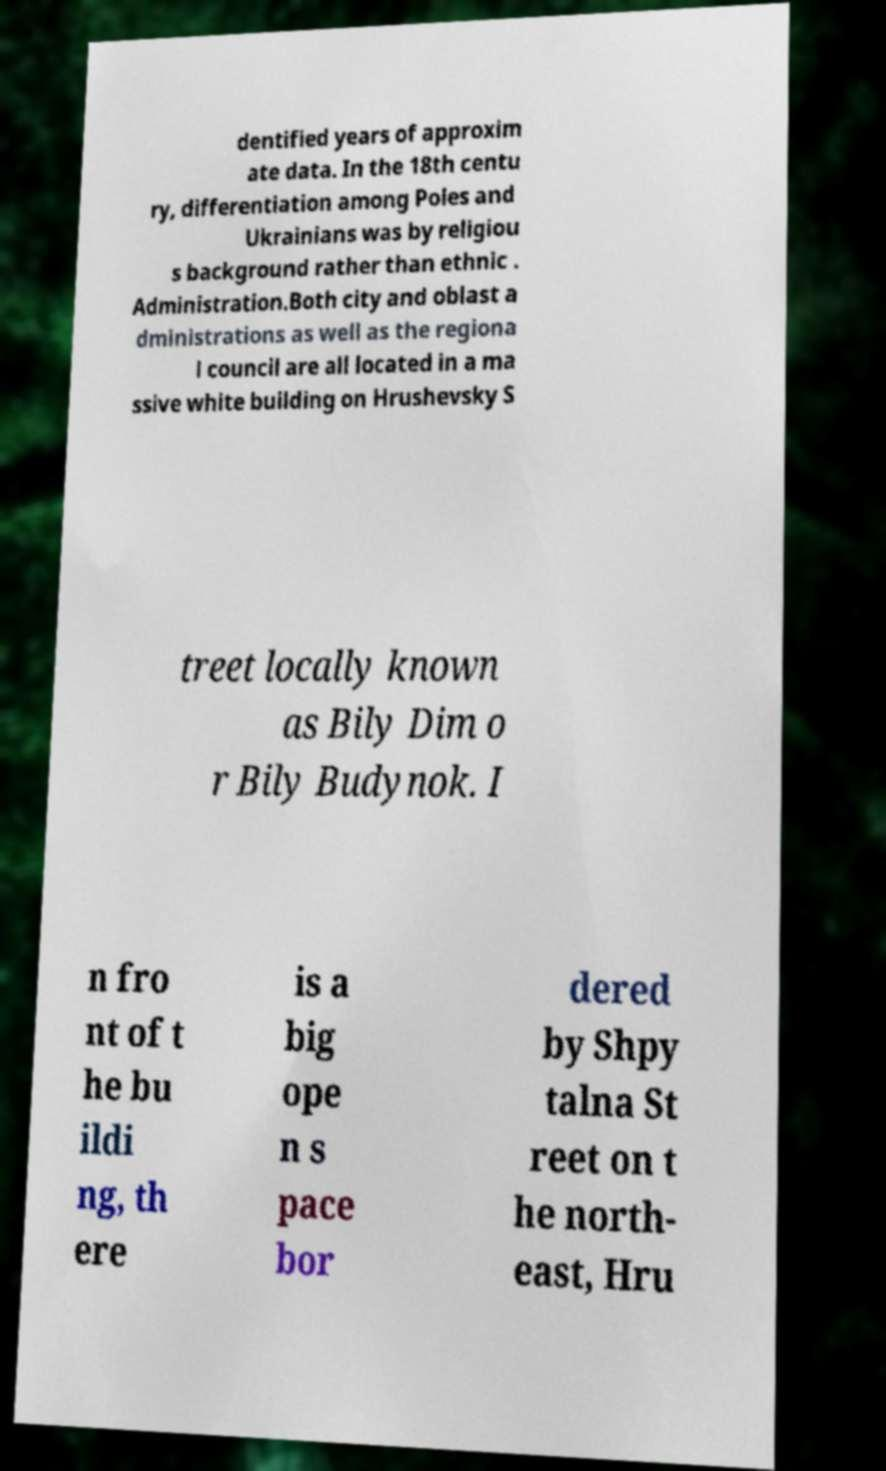Please identify and transcribe the text found in this image. dentified years of approxim ate data. In the 18th centu ry, differentiation among Poles and Ukrainians was by religiou s background rather than ethnic . Administration.Both city and oblast a dministrations as well as the regiona l council are all located in a ma ssive white building on Hrushevsky S treet locally known as Bily Dim o r Bily Budynok. I n fro nt of t he bu ildi ng, th ere is a big ope n s pace bor dered by Shpy talna St reet on t he north- east, Hru 